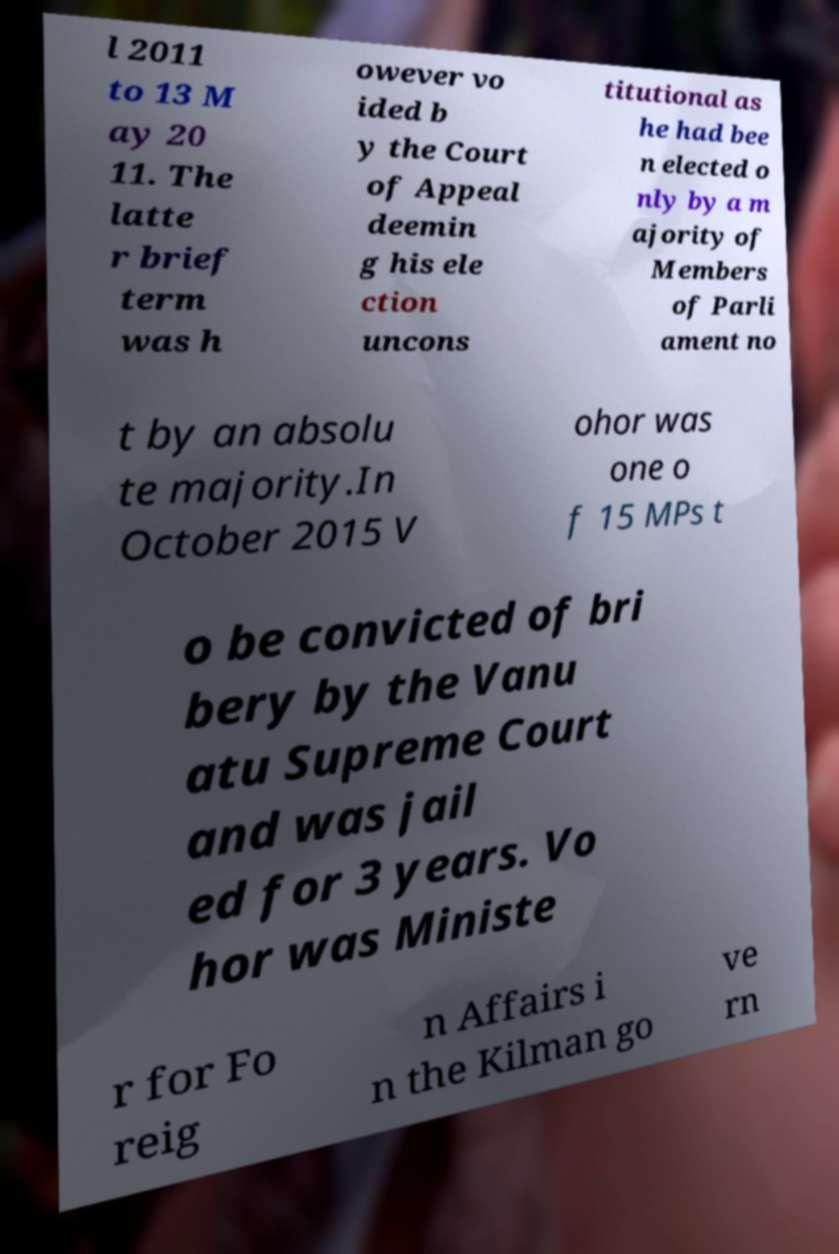Please read and relay the text visible in this image. What does it say? l 2011 to 13 M ay 20 11. The latte r brief term was h owever vo ided b y the Court of Appeal deemin g his ele ction uncons titutional as he had bee n elected o nly by a m ajority of Members of Parli ament no t by an absolu te majority.In October 2015 V ohor was one o f 15 MPs t o be convicted of bri bery by the Vanu atu Supreme Court and was jail ed for 3 years. Vo hor was Ministe r for Fo reig n Affairs i n the Kilman go ve rn 